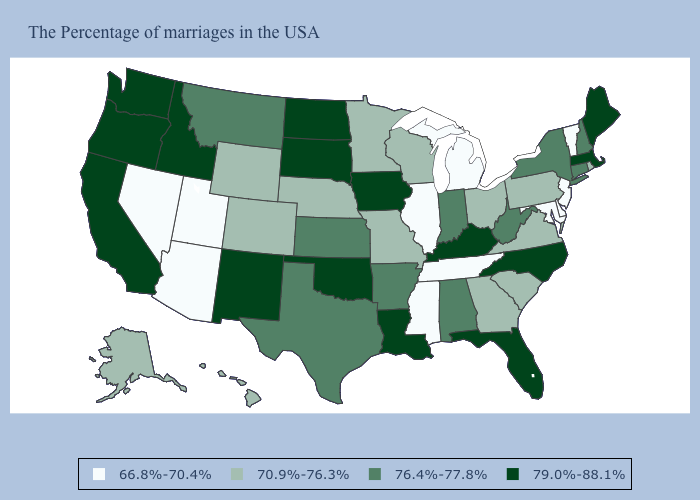Which states have the lowest value in the USA?
Short answer required. Vermont, New Jersey, Delaware, Maryland, Michigan, Tennessee, Illinois, Mississippi, Utah, Arizona, Nevada. Name the states that have a value in the range 70.9%-76.3%?
Concise answer only. Rhode Island, Pennsylvania, Virginia, South Carolina, Ohio, Georgia, Wisconsin, Missouri, Minnesota, Nebraska, Wyoming, Colorado, Alaska, Hawaii. Name the states that have a value in the range 70.9%-76.3%?
Give a very brief answer. Rhode Island, Pennsylvania, Virginia, South Carolina, Ohio, Georgia, Wisconsin, Missouri, Minnesota, Nebraska, Wyoming, Colorado, Alaska, Hawaii. Name the states that have a value in the range 79.0%-88.1%?
Be succinct. Maine, Massachusetts, North Carolina, Florida, Kentucky, Louisiana, Iowa, Oklahoma, South Dakota, North Dakota, New Mexico, Idaho, California, Washington, Oregon. What is the value of Montana?
Write a very short answer. 76.4%-77.8%. Which states have the lowest value in the West?
Write a very short answer. Utah, Arizona, Nevada. What is the lowest value in the South?
Keep it brief. 66.8%-70.4%. What is the lowest value in the USA?
Write a very short answer. 66.8%-70.4%. What is the lowest value in the USA?
Answer briefly. 66.8%-70.4%. Does Louisiana have the highest value in the South?
Quick response, please. Yes. Name the states that have a value in the range 79.0%-88.1%?
Answer briefly. Maine, Massachusetts, North Carolina, Florida, Kentucky, Louisiana, Iowa, Oklahoma, South Dakota, North Dakota, New Mexico, Idaho, California, Washington, Oregon. Among the states that border Mississippi , which have the lowest value?
Answer briefly. Tennessee. Name the states that have a value in the range 70.9%-76.3%?
Answer briefly. Rhode Island, Pennsylvania, Virginia, South Carolina, Ohio, Georgia, Wisconsin, Missouri, Minnesota, Nebraska, Wyoming, Colorado, Alaska, Hawaii. What is the value of Utah?
Short answer required. 66.8%-70.4%. Does the first symbol in the legend represent the smallest category?
Answer briefly. Yes. 